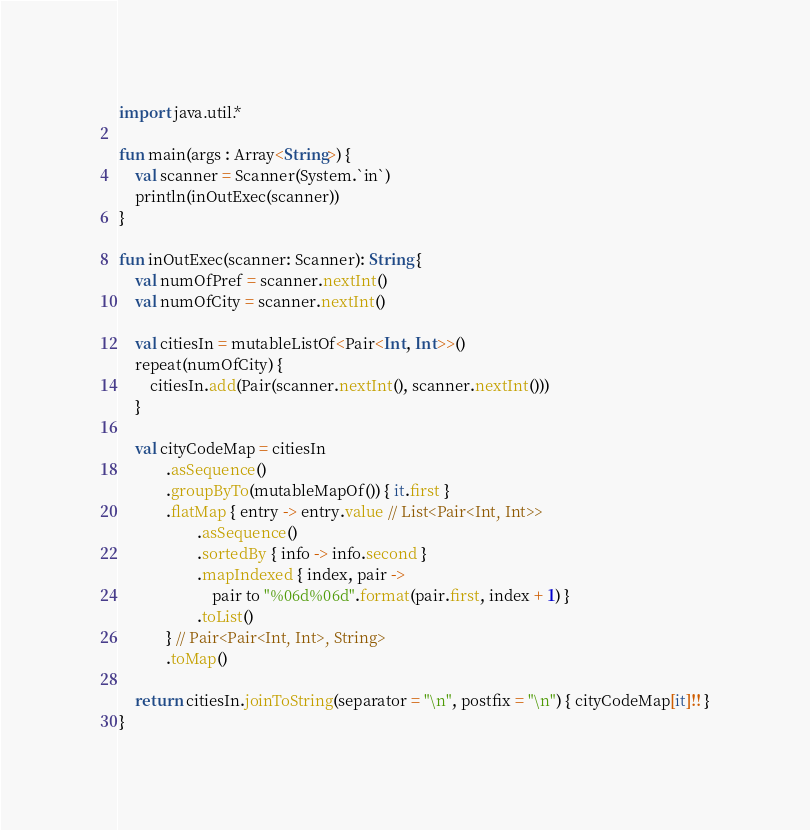<code> <loc_0><loc_0><loc_500><loc_500><_Kotlin_>import java.util.*

fun main(args : Array<String>) {
    val scanner = Scanner(System.`in`)
    println(inOutExec(scanner))
}

fun inOutExec(scanner: Scanner): String {
    val numOfPref = scanner.nextInt()
    val numOfCity = scanner.nextInt()

    val citiesIn = mutableListOf<Pair<Int, Int>>()
    repeat(numOfCity) {
        citiesIn.add(Pair(scanner.nextInt(), scanner.nextInt()))
    }

    val cityCodeMap = citiesIn
            .asSequence()
            .groupByTo(mutableMapOf()) { it.first }
            .flatMap { entry -> entry.value // List<Pair<Int, Int>>
                    .asSequence()
                    .sortedBy { info -> info.second }
                    .mapIndexed { index, pair ->
                        pair to "%06d%06d".format(pair.first, index + 1) }
                    .toList()
            } // Pair<Pair<Int, Int>, String>
            .toMap()

    return citiesIn.joinToString(separator = "\n", postfix = "\n") { cityCodeMap[it]!! }
}</code> 